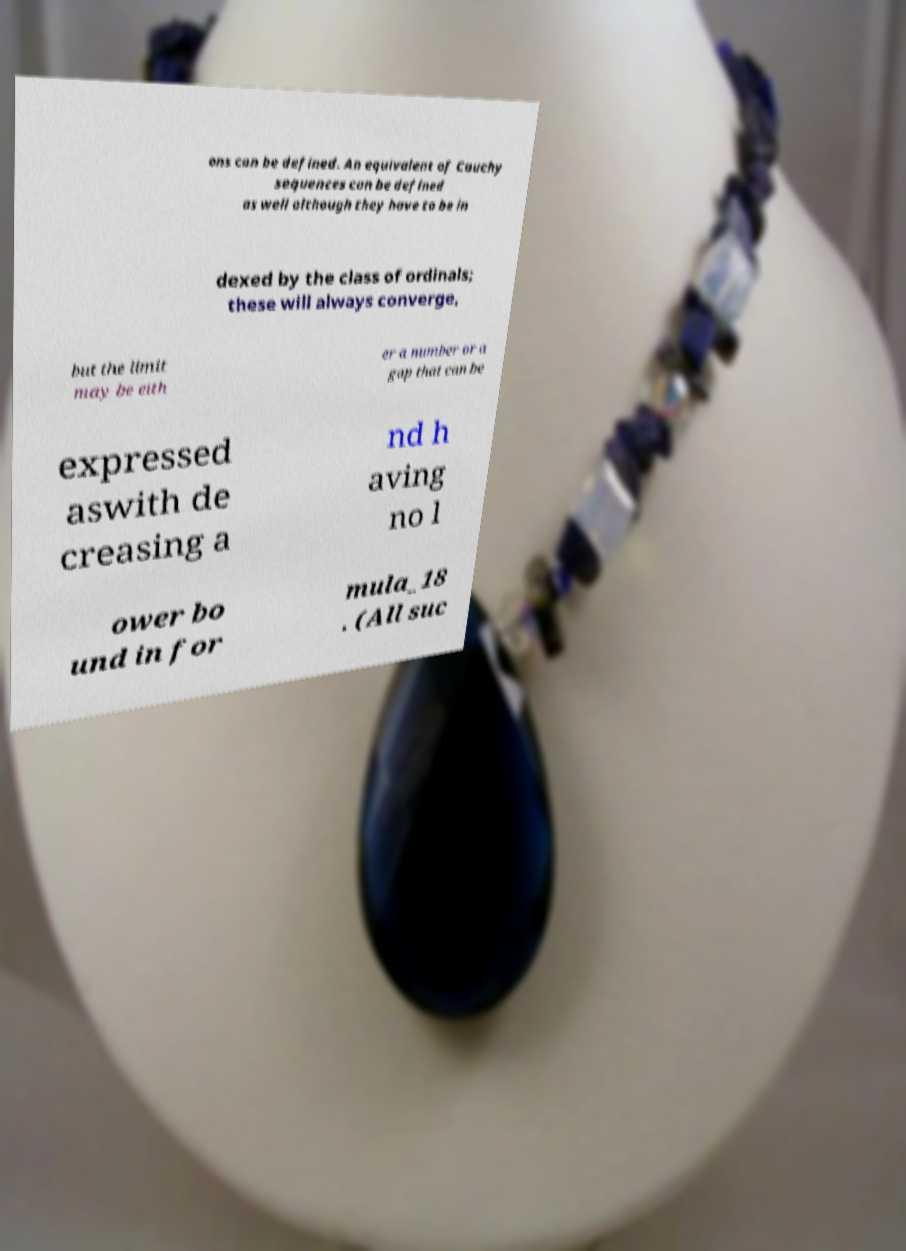Can you accurately transcribe the text from the provided image for me? ons can be defined. An equivalent of Cauchy sequences can be defined as well although they have to be in dexed by the class of ordinals; these will always converge, but the limit may be eith er a number or a gap that can be expressed aswith de creasing a nd h aving no l ower bo und in for mula_18 . (All suc 